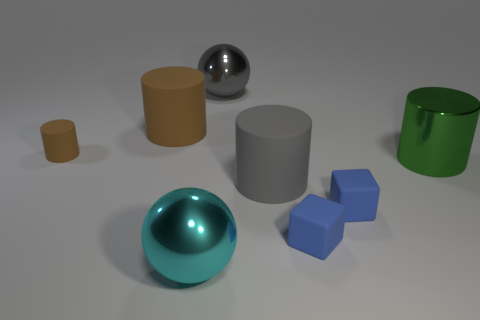There is a ball that is on the right side of the cyan thing; what is its material?
Make the answer very short. Metal. There is a large cylinder behind the metallic cylinder; is it the same color as the ball behind the cyan object?
Your response must be concise. No. What color is the shiny cylinder that is the same size as the cyan metallic sphere?
Offer a very short reply. Green. What number of other things are the same shape as the large green object?
Offer a terse response. 3. What size is the shiny ball behind the green metallic cylinder?
Offer a terse response. Large. There is a big gray object behind the tiny brown thing; what number of metallic balls are in front of it?
Your response must be concise. 1. How many other objects are the same size as the cyan metallic thing?
Provide a succinct answer. 4. Is the tiny rubber cylinder the same color as the shiny cylinder?
Make the answer very short. No. There is a small object that is left of the gray shiny object; does it have the same shape as the cyan thing?
Give a very brief answer. No. How many shiny balls are both behind the big cyan object and in front of the big green metal cylinder?
Provide a short and direct response. 0. 